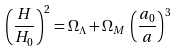Convert formula to latex. <formula><loc_0><loc_0><loc_500><loc_500>\left ( \frac { H } { H _ { 0 } } \right ) ^ { 2 } = \Omega _ { \Lambda } + \Omega _ { M } \, \left ( \frac { a _ { 0 } } { a } \right ) ^ { 3 }</formula> 